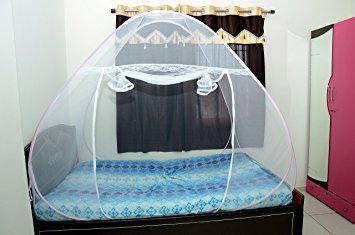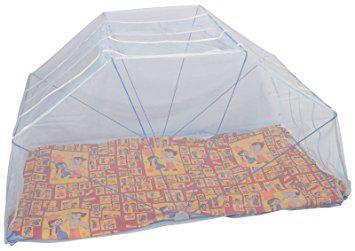The first image is the image on the left, the second image is the image on the right. Evaluate the accuracy of this statement regarding the images: "One of the mattresses is blue and white.". Is it true? Answer yes or no. Yes. 